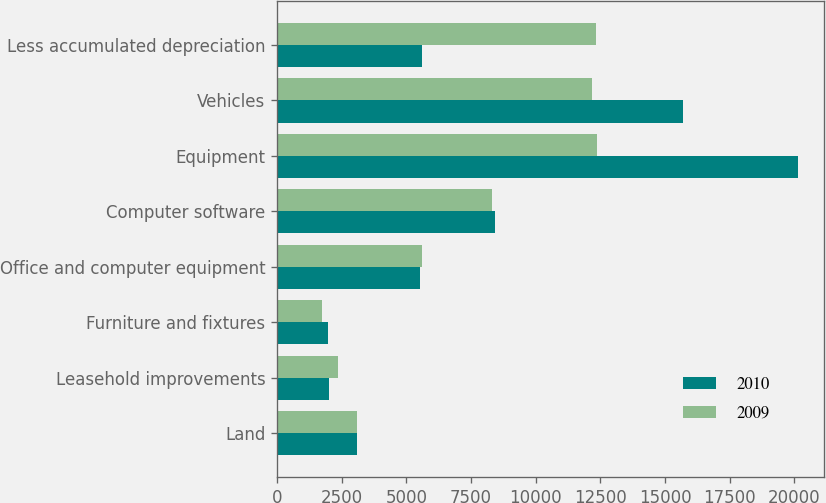<chart> <loc_0><loc_0><loc_500><loc_500><stacked_bar_chart><ecel><fcel>Land<fcel>Leasehold improvements<fcel>Furniture and fixtures<fcel>Office and computer equipment<fcel>Computer software<fcel>Equipment<fcel>Vehicles<fcel>Less accumulated depreciation<nl><fcel>2010<fcel>3076<fcel>1998<fcel>1959<fcel>5541<fcel>8428<fcel>20150<fcel>15696<fcel>5585<nl><fcel>2009<fcel>3076<fcel>2365<fcel>1752<fcel>5585<fcel>8313<fcel>12377<fcel>12170<fcel>12324<nl></chart> 